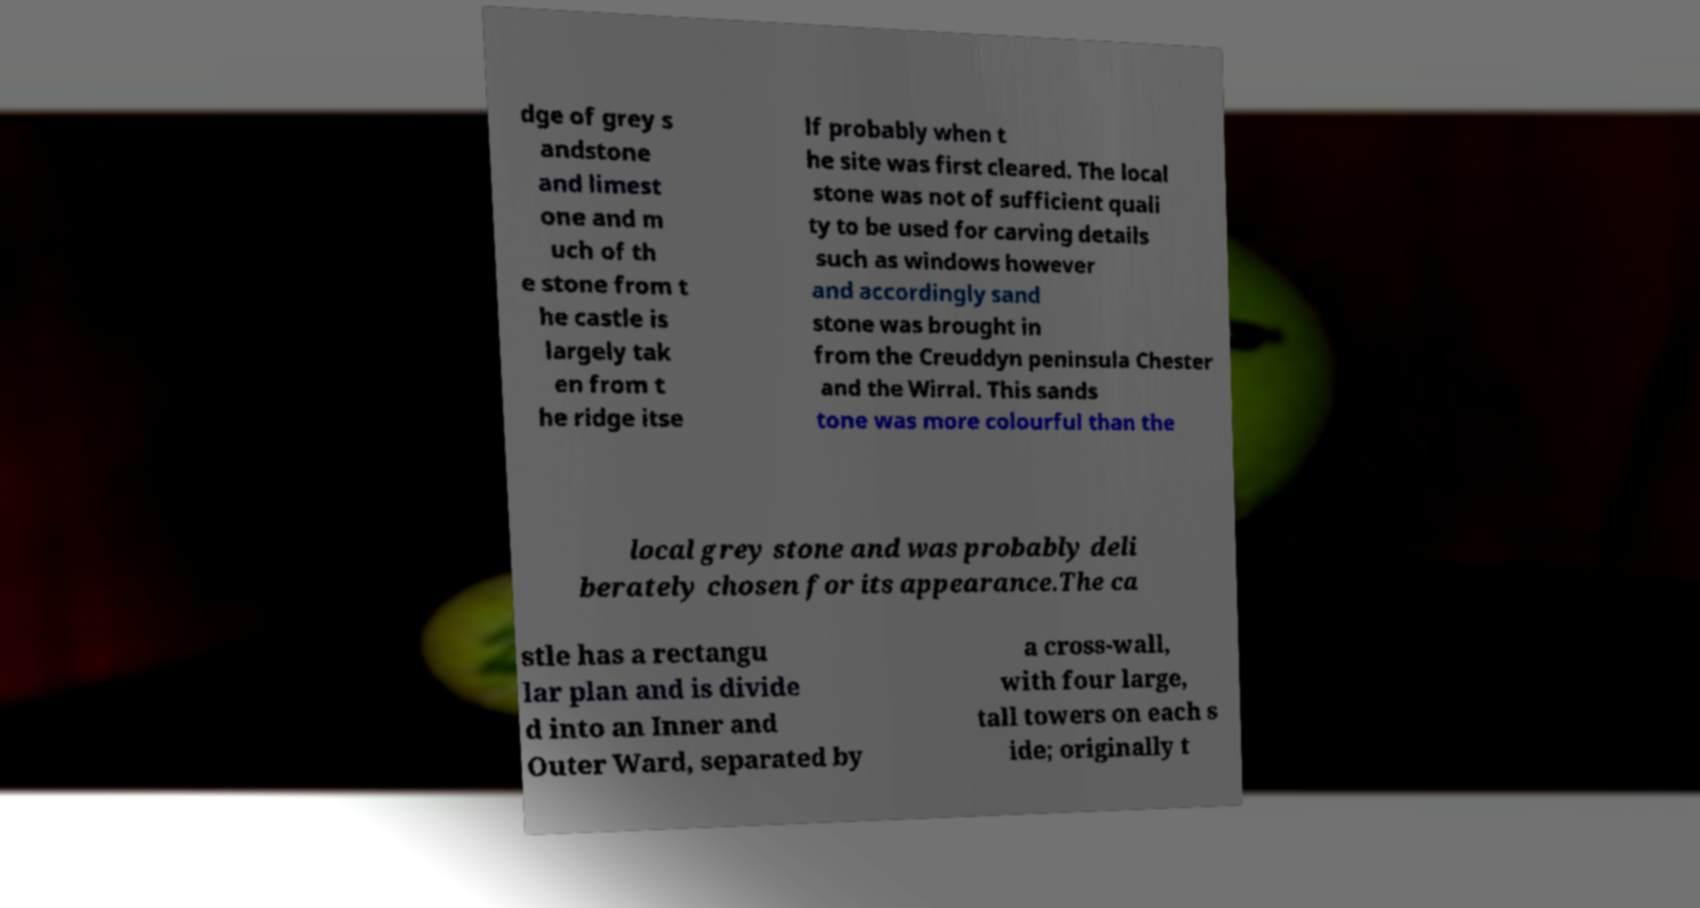Can you accurately transcribe the text from the provided image for me? dge of grey s andstone and limest one and m uch of th e stone from t he castle is largely tak en from t he ridge itse lf probably when t he site was first cleared. The local stone was not of sufficient quali ty to be used for carving details such as windows however and accordingly sand stone was brought in from the Creuddyn peninsula Chester and the Wirral. This sands tone was more colourful than the local grey stone and was probably deli berately chosen for its appearance.The ca stle has a rectangu lar plan and is divide d into an Inner and Outer Ward, separated by a cross-wall, with four large, tall towers on each s ide; originally t 